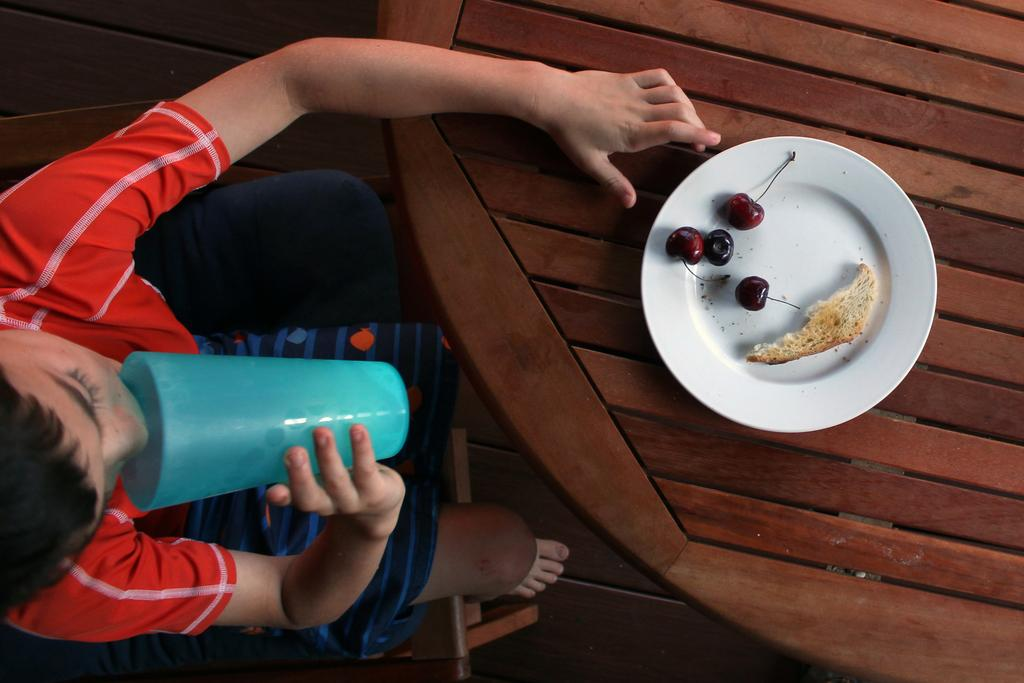What is on the plate that is visible in the image? The plate contains cherries and a bread slice. Where is the plate located in the image? The plate is placed on a table. Who is present in the image? There is a boy in the image. What is the boy holding in the image? The boy is holding a glass. What is the boy drinking in the image? The boy is drinking water. What is the boy's position in the image? The boy is sitting on a chair. What type of cover is on the yam in the image? There is no yam or cover present in the image. Where is the boy placing the yam in the image? There is no yam in the image, so it cannot be placed anywhere. 